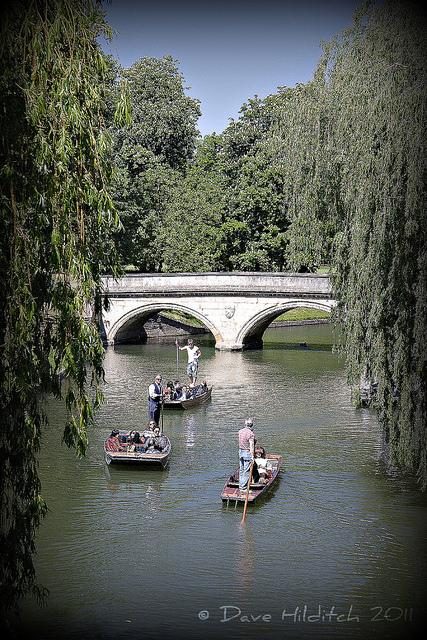Why are some people standing in the boats? Please explain your reasoning. gondoliers. The people that are standing are the ones that are holding the paddles. 